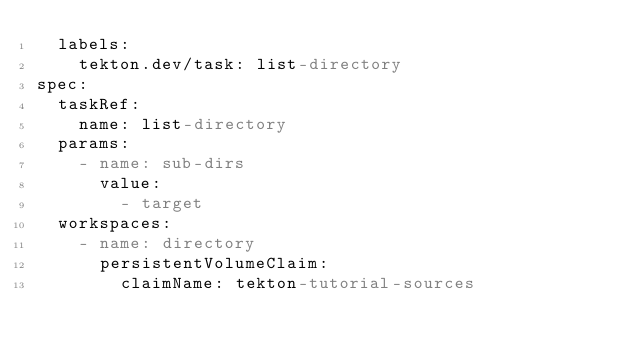<code> <loc_0><loc_0><loc_500><loc_500><_YAML_>  labels:
    tekton.dev/task: list-directory
spec:
  taskRef:
    name: list-directory
  params:
    - name: sub-dirs
      value:
        - target
  workspaces:
    - name: directory
      persistentVolumeClaim:
        claimName: tekton-tutorial-sources
</code> 